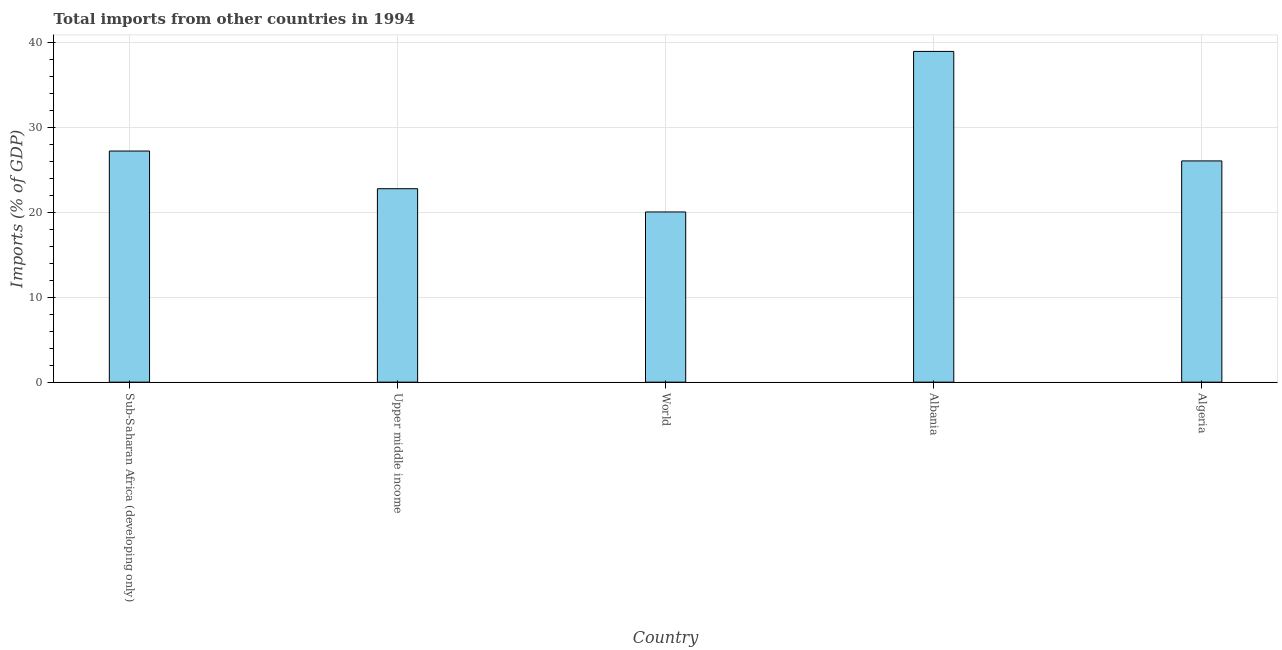Does the graph contain grids?
Provide a short and direct response. Yes. What is the title of the graph?
Ensure brevity in your answer.  Total imports from other countries in 1994. What is the label or title of the X-axis?
Give a very brief answer. Country. What is the label or title of the Y-axis?
Offer a terse response. Imports (% of GDP). What is the total imports in Sub-Saharan Africa (developing only)?
Offer a terse response. 27.22. Across all countries, what is the maximum total imports?
Provide a short and direct response. 38.95. Across all countries, what is the minimum total imports?
Your answer should be very brief. 20.04. In which country was the total imports maximum?
Your response must be concise. Albania. In which country was the total imports minimum?
Keep it short and to the point. World. What is the sum of the total imports?
Give a very brief answer. 135.04. What is the difference between the total imports in Sub-Saharan Africa (developing only) and World?
Your response must be concise. 7.17. What is the average total imports per country?
Your answer should be compact. 27.01. What is the median total imports?
Your answer should be very brief. 26.05. What is the ratio of the total imports in Algeria to that in Upper middle income?
Your answer should be compact. 1.14. Is the total imports in Albania less than that in Upper middle income?
Offer a very short reply. No. What is the difference between the highest and the second highest total imports?
Your response must be concise. 11.73. What is the difference between the highest and the lowest total imports?
Your answer should be very brief. 18.91. Are all the bars in the graph horizontal?
Your answer should be very brief. No. What is the difference between two consecutive major ticks on the Y-axis?
Offer a terse response. 10. What is the Imports (% of GDP) in Sub-Saharan Africa (developing only)?
Offer a terse response. 27.22. What is the Imports (% of GDP) in Upper middle income?
Give a very brief answer. 22.78. What is the Imports (% of GDP) of World?
Ensure brevity in your answer.  20.04. What is the Imports (% of GDP) in Albania?
Your answer should be very brief. 38.95. What is the Imports (% of GDP) of Algeria?
Ensure brevity in your answer.  26.05. What is the difference between the Imports (% of GDP) in Sub-Saharan Africa (developing only) and Upper middle income?
Your response must be concise. 4.44. What is the difference between the Imports (% of GDP) in Sub-Saharan Africa (developing only) and World?
Ensure brevity in your answer.  7.18. What is the difference between the Imports (% of GDP) in Sub-Saharan Africa (developing only) and Albania?
Offer a very short reply. -11.73. What is the difference between the Imports (% of GDP) in Sub-Saharan Africa (developing only) and Algeria?
Provide a short and direct response. 1.16. What is the difference between the Imports (% of GDP) in Upper middle income and World?
Offer a very short reply. 2.74. What is the difference between the Imports (% of GDP) in Upper middle income and Albania?
Offer a terse response. -16.17. What is the difference between the Imports (% of GDP) in Upper middle income and Algeria?
Your answer should be very brief. -3.27. What is the difference between the Imports (% of GDP) in World and Albania?
Provide a short and direct response. -18.91. What is the difference between the Imports (% of GDP) in World and Algeria?
Offer a very short reply. -6.01. What is the difference between the Imports (% of GDP) in Albania and Algeria?
Offer a very short reply. 12.9. What is the ratio of the Imports (% of GDP) in Sub-Saharan Africa (developing only) to that in Upper middle income?
Keep it short and to the point. 1.2. What is the ratio of the Imports (% of GDP) in Sub-Saharan Africa (developing only) to that in World?
Keep it short and to the point. 1.36. What is the ratio of the Imports (% of GDP) in Sub-Saharan Africa (developing only) to that in Albania?
Provide a succinct answer. 0.7. What is the ratio of the Imports (% of GDP) in Sub-Saharan Africa (developing only) to that in Algeria?
Make the answer very short. 1.04. What is the ratio of the Imports (% of GDP) in Upper middle income to that in World?
Ensure brevity in your answer.  1.14. What is the ratio of the Imports (% of GDP) in Upper middle income to that in Albania?
Your answer should be compact. 0.58. What is the ratio of the Imports (% of GDP) in Upper middle income to that in Algeria?
Give a very brief answer. 0.87. What is the ratio of the Imports (% of GDP) in World to that in Albania?
Provide a short and direct response. 0.52. What is the ratio of the Imports (% of GDP) in World to that in Algeria?
Provide a short and direct response. 0.77. What is the ratio of the Imports (% of GDP) in Albania to that in Algeria?
Offer a terse response. 1.5. 